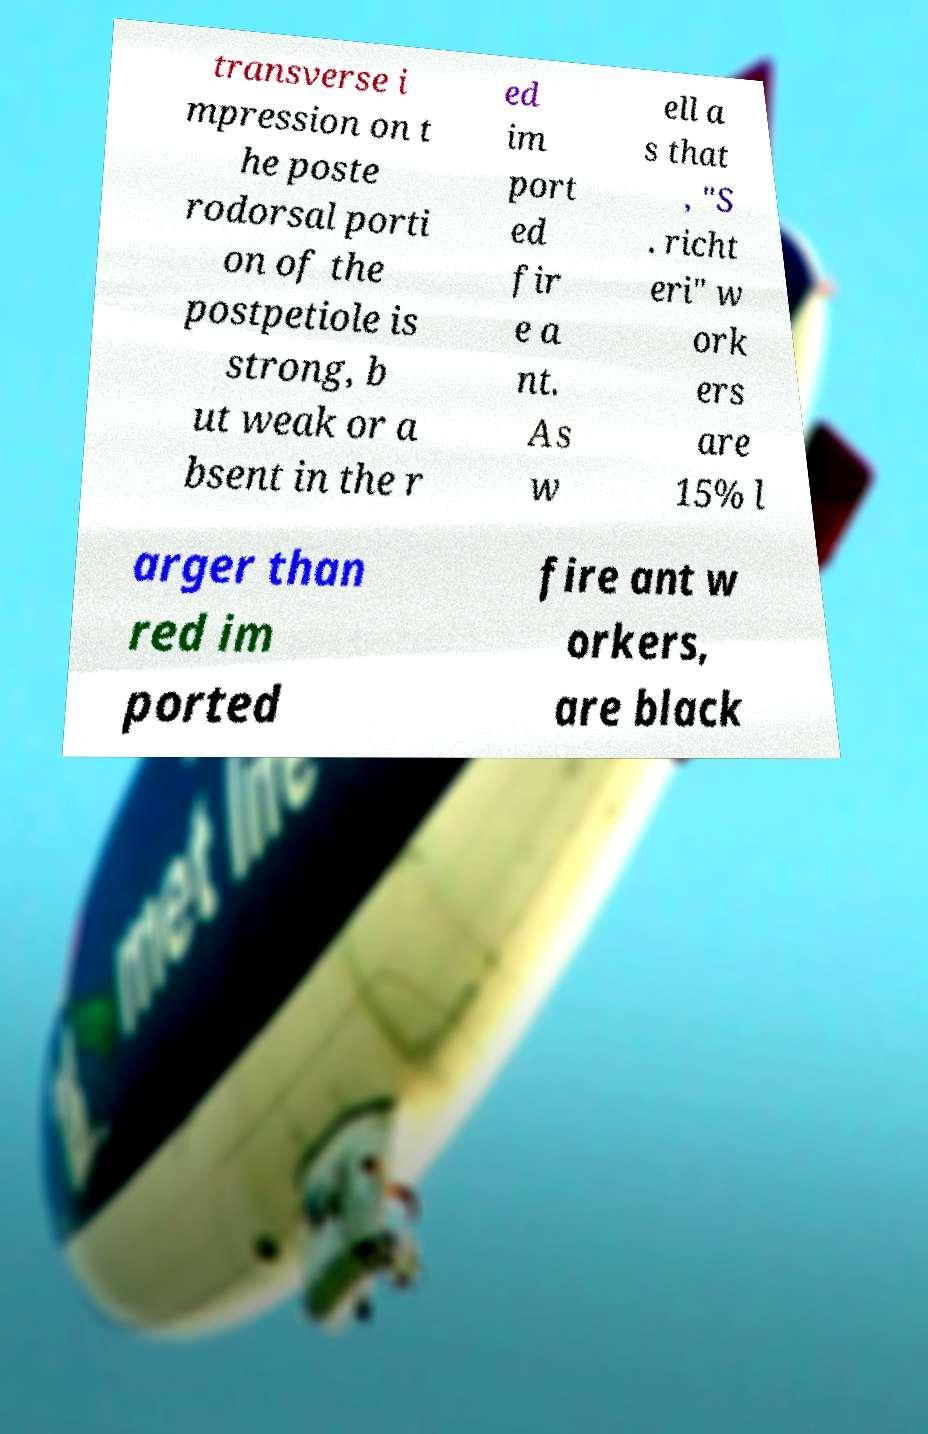I need the written content from this picture converted into text. Can you do that? transverse i mpression on t he poste rodorsal porti on of the postpetiole is strong, b ut weak or a bsent in the r ed im port ed fir e a nt. As w ell a s that , "S . richt eri" w ork ers are 15% l arger than red im ported fire ant w orkers, are black 